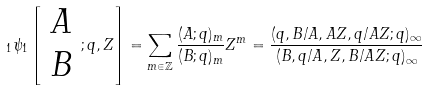Convert formula to latex. <formula><loc_0><loc_0><loc_500><loc_500>\, _ { 1 } \psi _ { 1 } \left [ \begin{array} { c } A \\ B \end{array} ; q , Z \right ] = \sum _ { m \in \mathbb { Z } } \frac { ( A ; q ) _ { m } } { ( B ; q ) _ { m } } Z ^ { m } = \frac { ( q , B / A , A Z , q / A Z ; q ) _ { \infty } } { ( B , q / A , Z , B / A Z ; q ) _ { \infty } }</formula> 